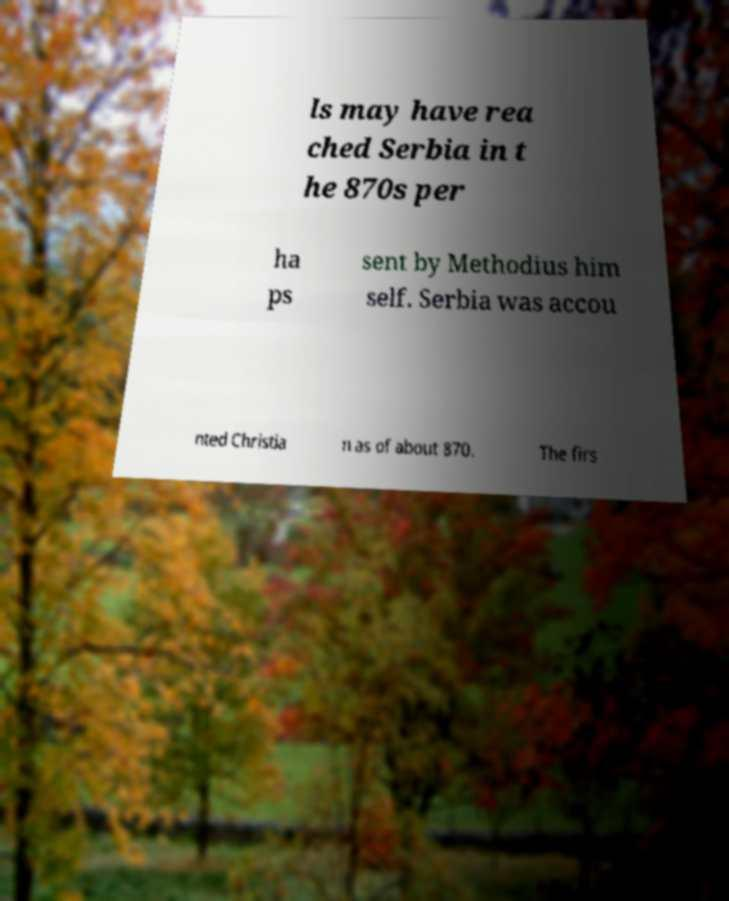Could you assist in decoding the text presented in this image and type it out clearly? ls may have rea ched Serbia in t he 870s per ha ps sent by Methodius him self. Serbia was accou nted Christia n as of about 870. The firs 